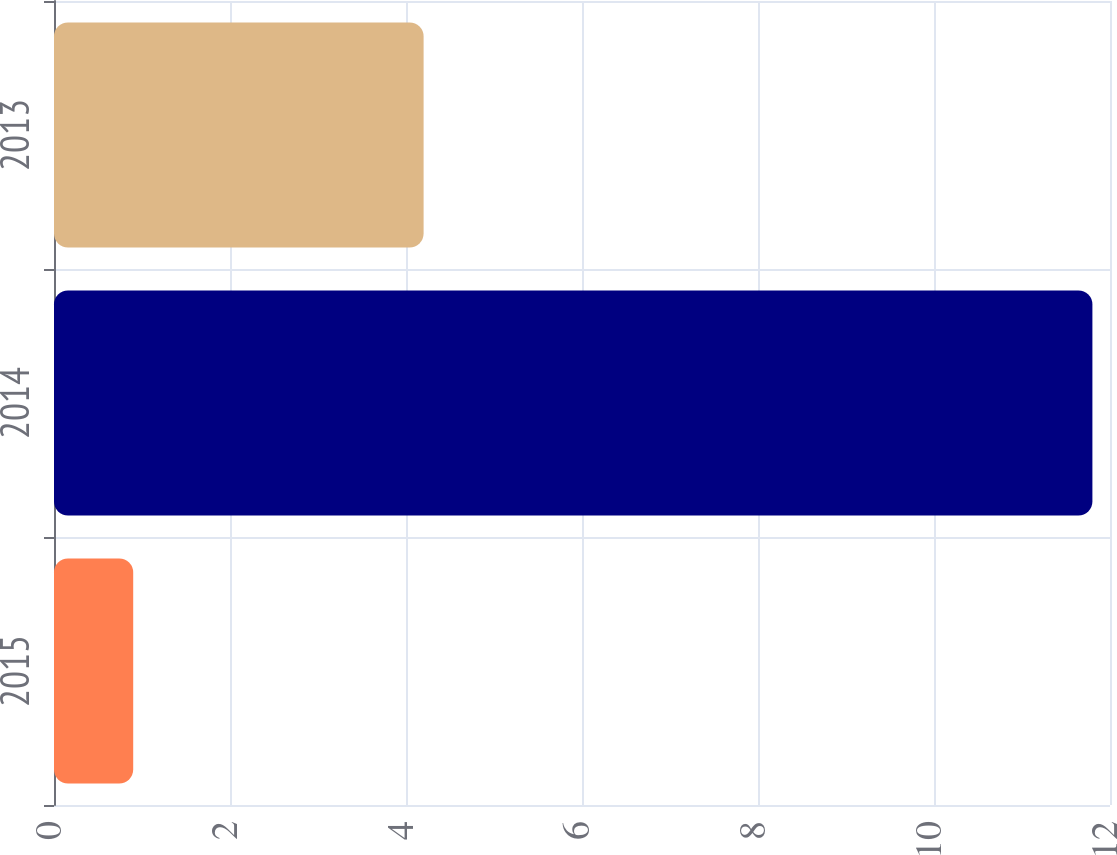Convert chart to OTSL. <chart><loc_0><loc_0><loc_500><loc_500><bar_chart><fcel>2015<fcel>2014<fcel>2013<nl><fcel>0.9<fcel>11.8<fcel>4.2<nl></chart> 